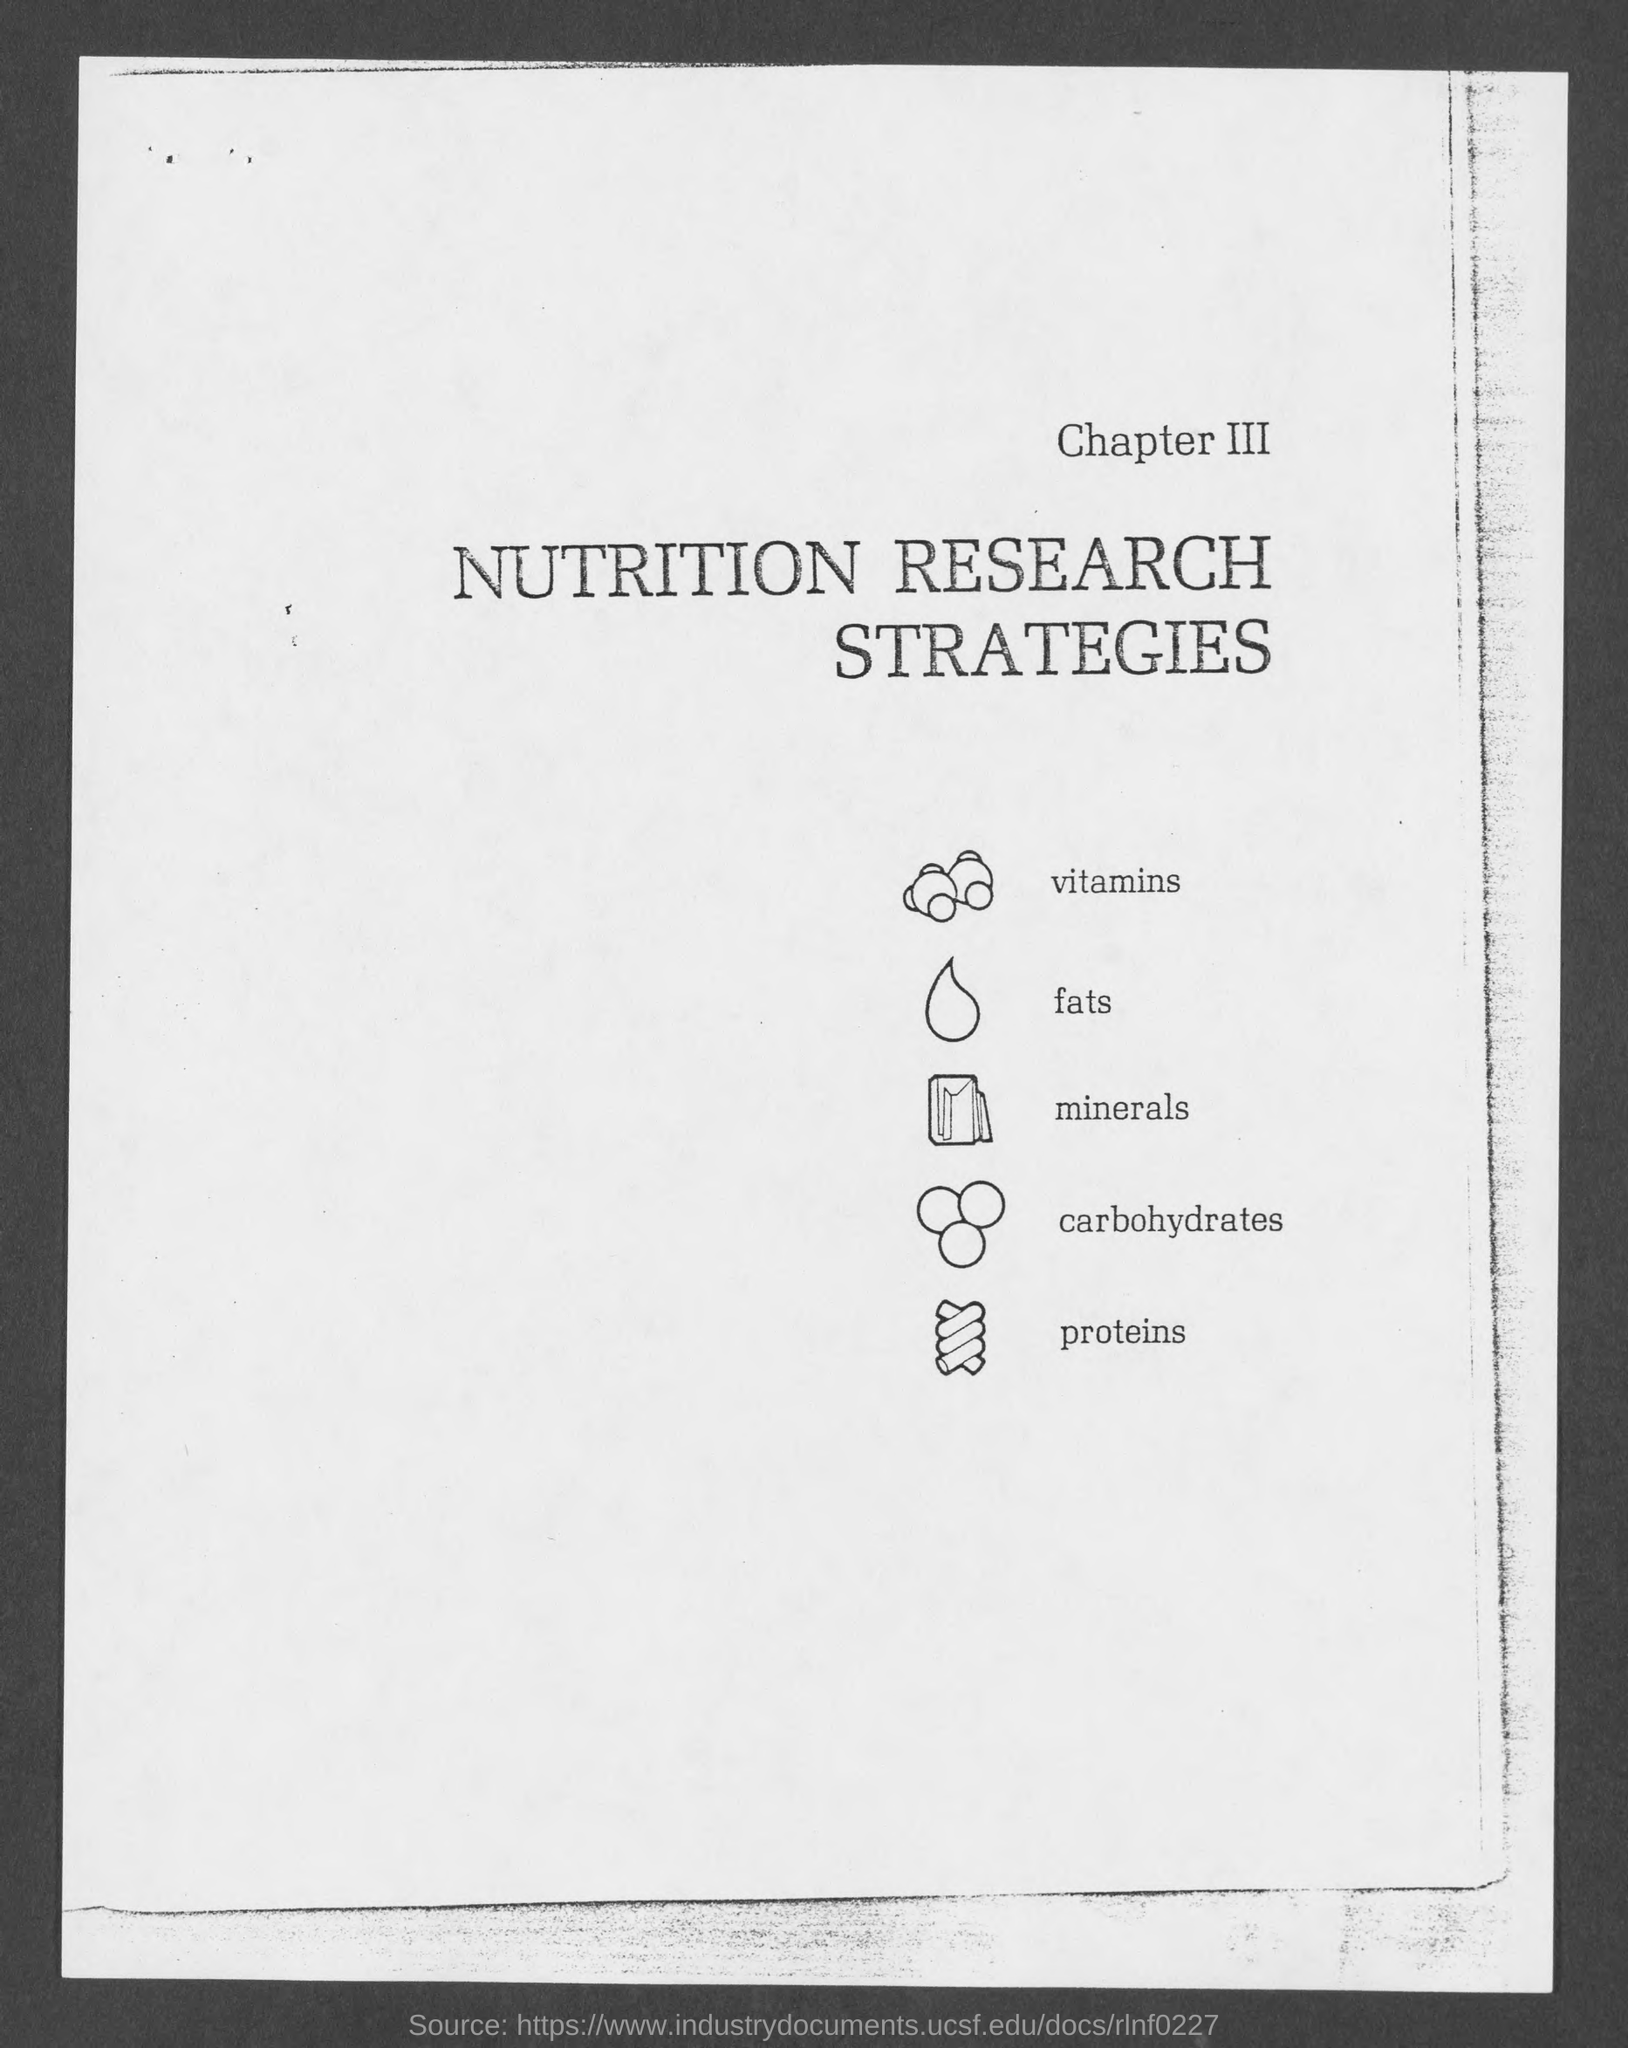Identify some key points in this picture. Chapter III explores various nutrition research strategies for enhancing overall health and wellness. 